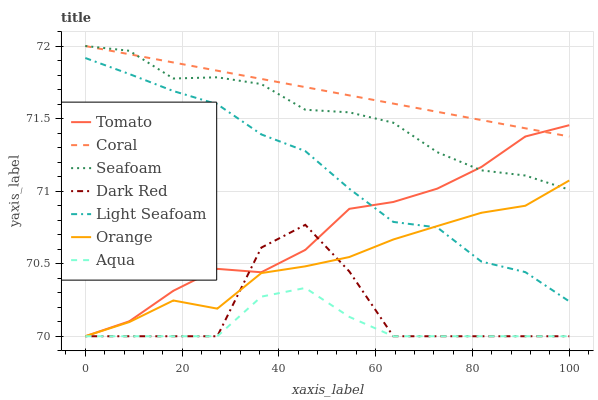Does Aqua have the minimum area under the curve?
Answer yes or no. Yes. Does Coral have the maximum area under the curve?
Answer yes or no. Yes. Does Dark Red have the minimum area under the curve?
Answer yes or no. No. Does Dark Red have the maximum area under the curve?
Answer yes or no. No. Is Coral the smoothest?
Answer yes or no. Yes. Is Dark Red the roughest?
Answer yes or no. Yes. Is Dark Red the smoothest?
Answer yes or no. No. Is Coral the roughest?
Answer yes or no. No. Does Tomato have the lowest value?
Answer yes or no. Yes. Does Coral have the lowest value?
Answer yes or no. No. Does Seafoam have the highest value?
Answer yes or no. Yes. Does Dark Red have the highest value?
Answer yes or no. No. Is Light Seafoam less than Seafoam?
Answer yes or no. Yes. Is Coral greater than Dark Red?
Answer yes or no. Yes. Does Tomato intersect Aqua?
Answer yes or no. Yes. Is Tomato less than Aqua?
Answer yes or no. No. Is Tomato greater than Aqua?
Answer yes or no. No. Does Light Seafoam intersect Seafoam?
Answer yes or no. No. 